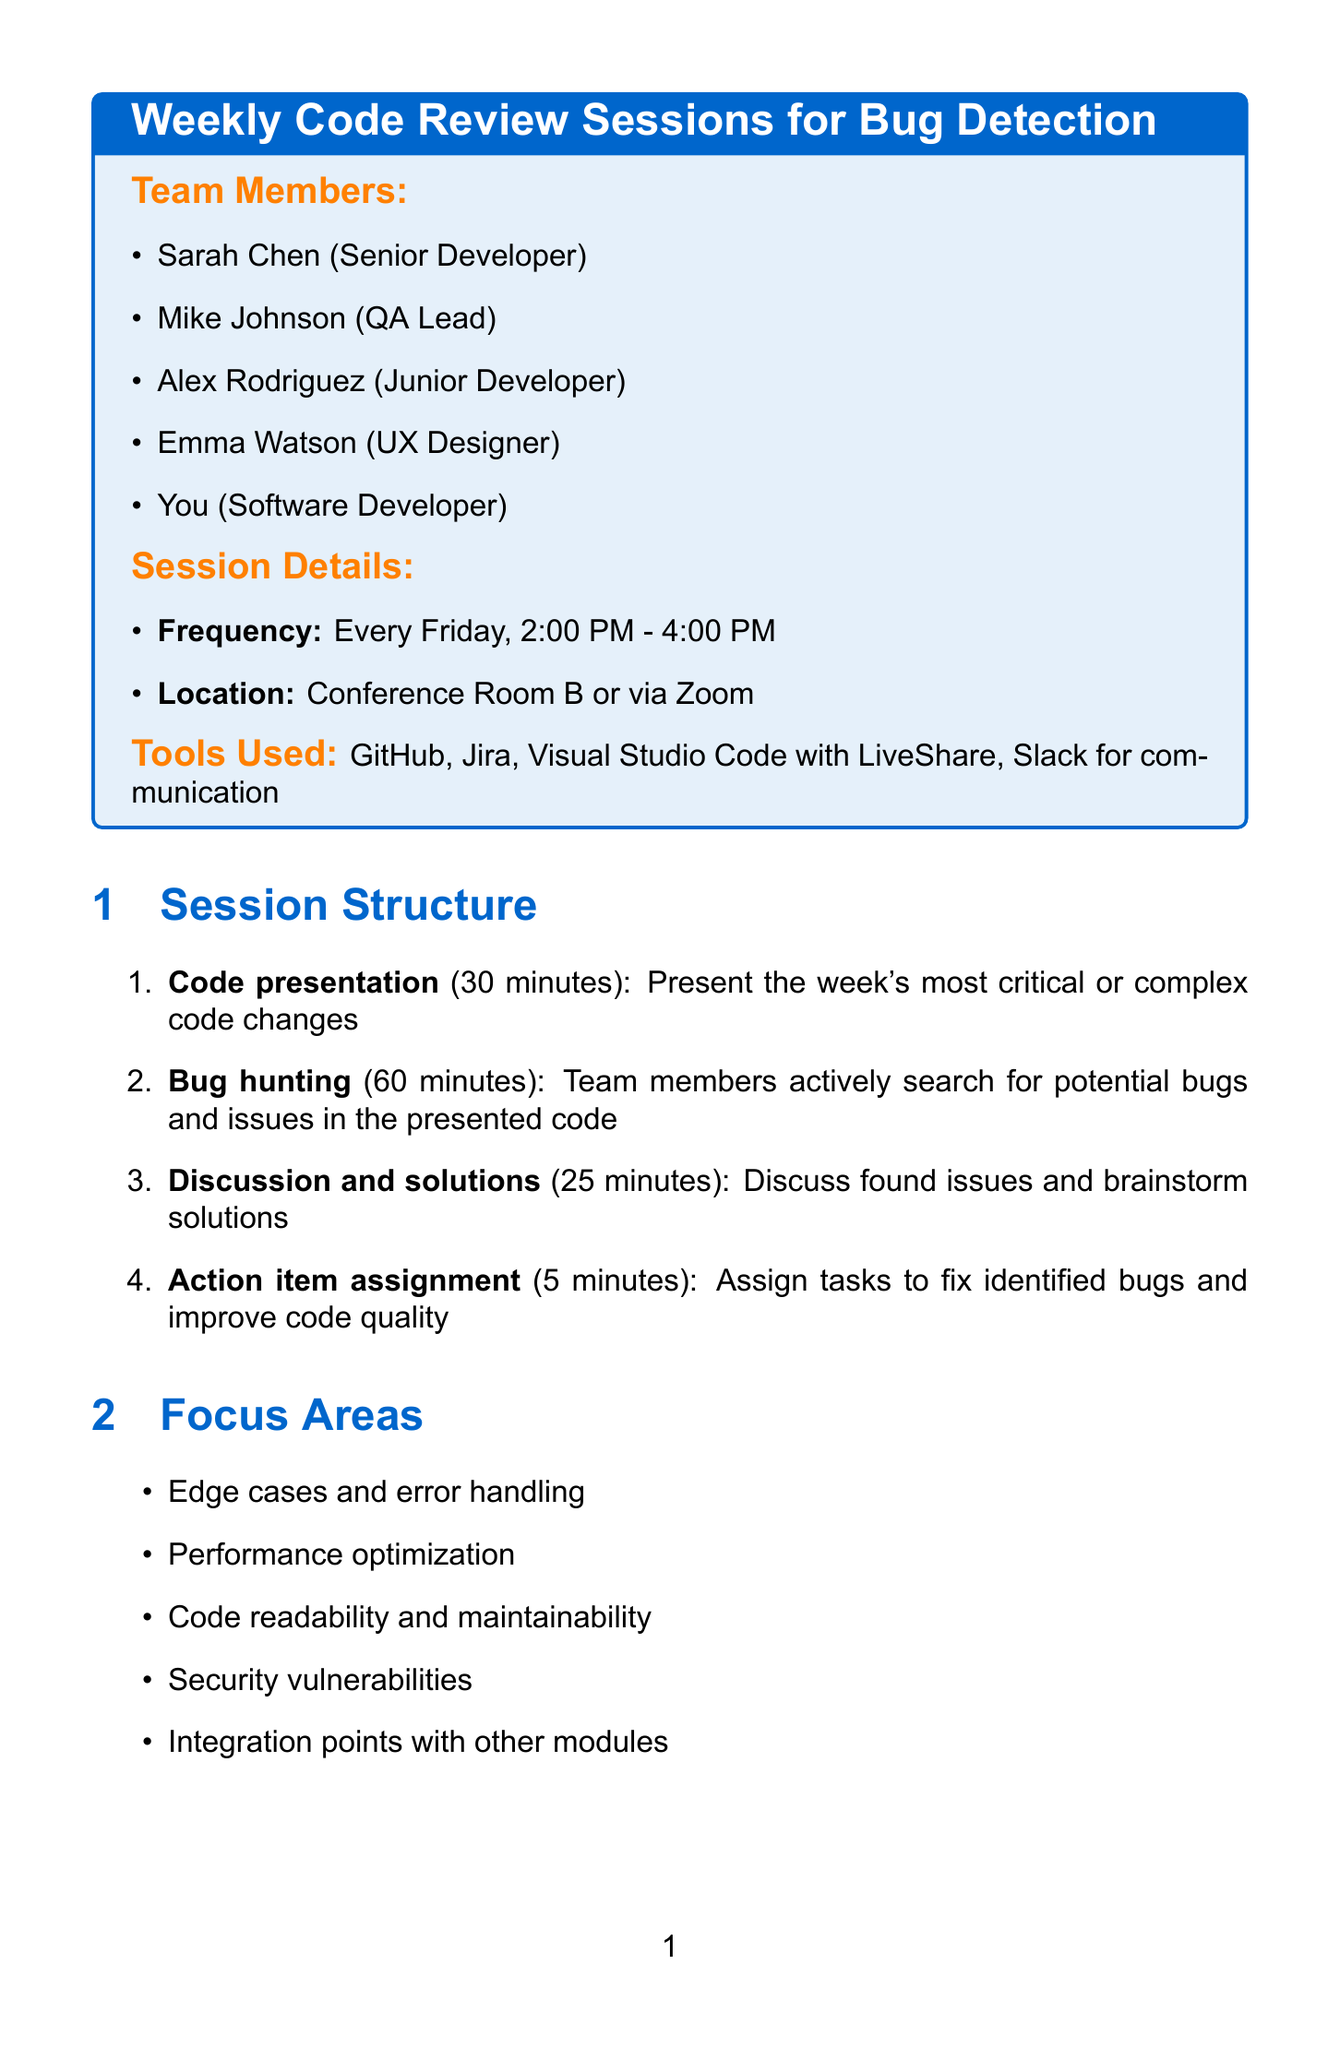What is the frequency of the code review sessions? The frequency of the code review sessions is stated in the document as "Every Friday, 2:00 PM - 4:00 PM."
Answer: Every Friday, 2:00 PM - 4:00 PM Who is the QA lead on the team? The document lists team members, identifying "Mike Johnson" as the QA Lead.
Answer: Mike Johnson What tool is used for communication during the sessions? The document mentions "Slack for communication" as one of the tools used during the sessions.
Answer: Slack How long is the bug hunting activity? The duration of the bug hunting activity is specified as 60 minutes in the session structure.
Answer: 60 minutes What is one of the focus areas for the sessions? The document lists focus areas, and one example is "Security vulnerabilities."
Answer: Security vulnerabilities How many preparation tasks are listed in the document? The document outlines preparation tasks, specifically listing four tasks required before the session.
Answer: Four What happens after the session regarding bugs? According to the document, newly discovered bugs are updated in "Jira."
Answer: Update Jira What is one success metric for the code reviews? The document mentions several success metrics, one of which is "Number of bugs caught during review vs. production."
Answer: Number of bugs caught during review vs. production How long is the action item assignment activity in the structure? The duration for the action item assignment activity is stated in the session structure as 5 minutes.
Answer: 5 minutes 